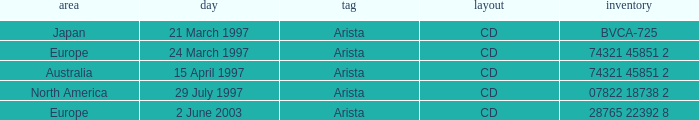What's listed for the Label with a Date of 29 July 1997? Arista. 